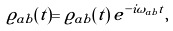Convert formula to latex. <formula><loc_0><loc_0><loc_500><loc_500>\varrho _ { a b } ( t ) = \tilde { \varrho } _ { a b } ( t ) \, e ^ { - i \omega _ { a b } t } ,</formula> 